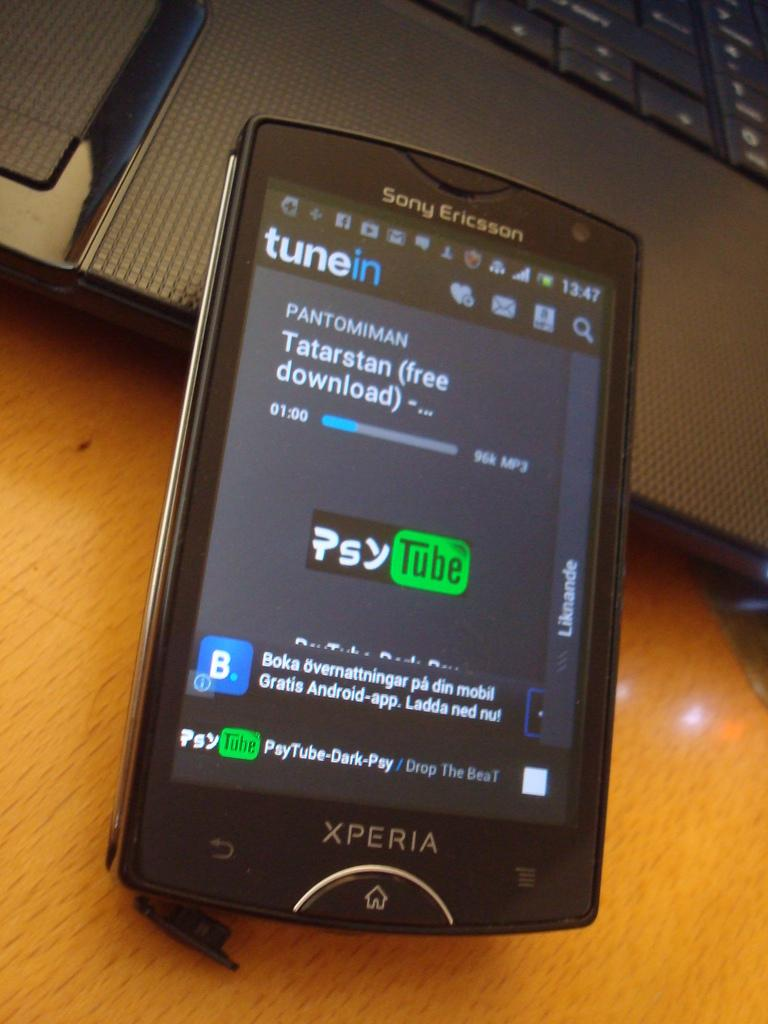<image>
Create a compact narrative representing the image presented. A phone screen of an app called tunein 